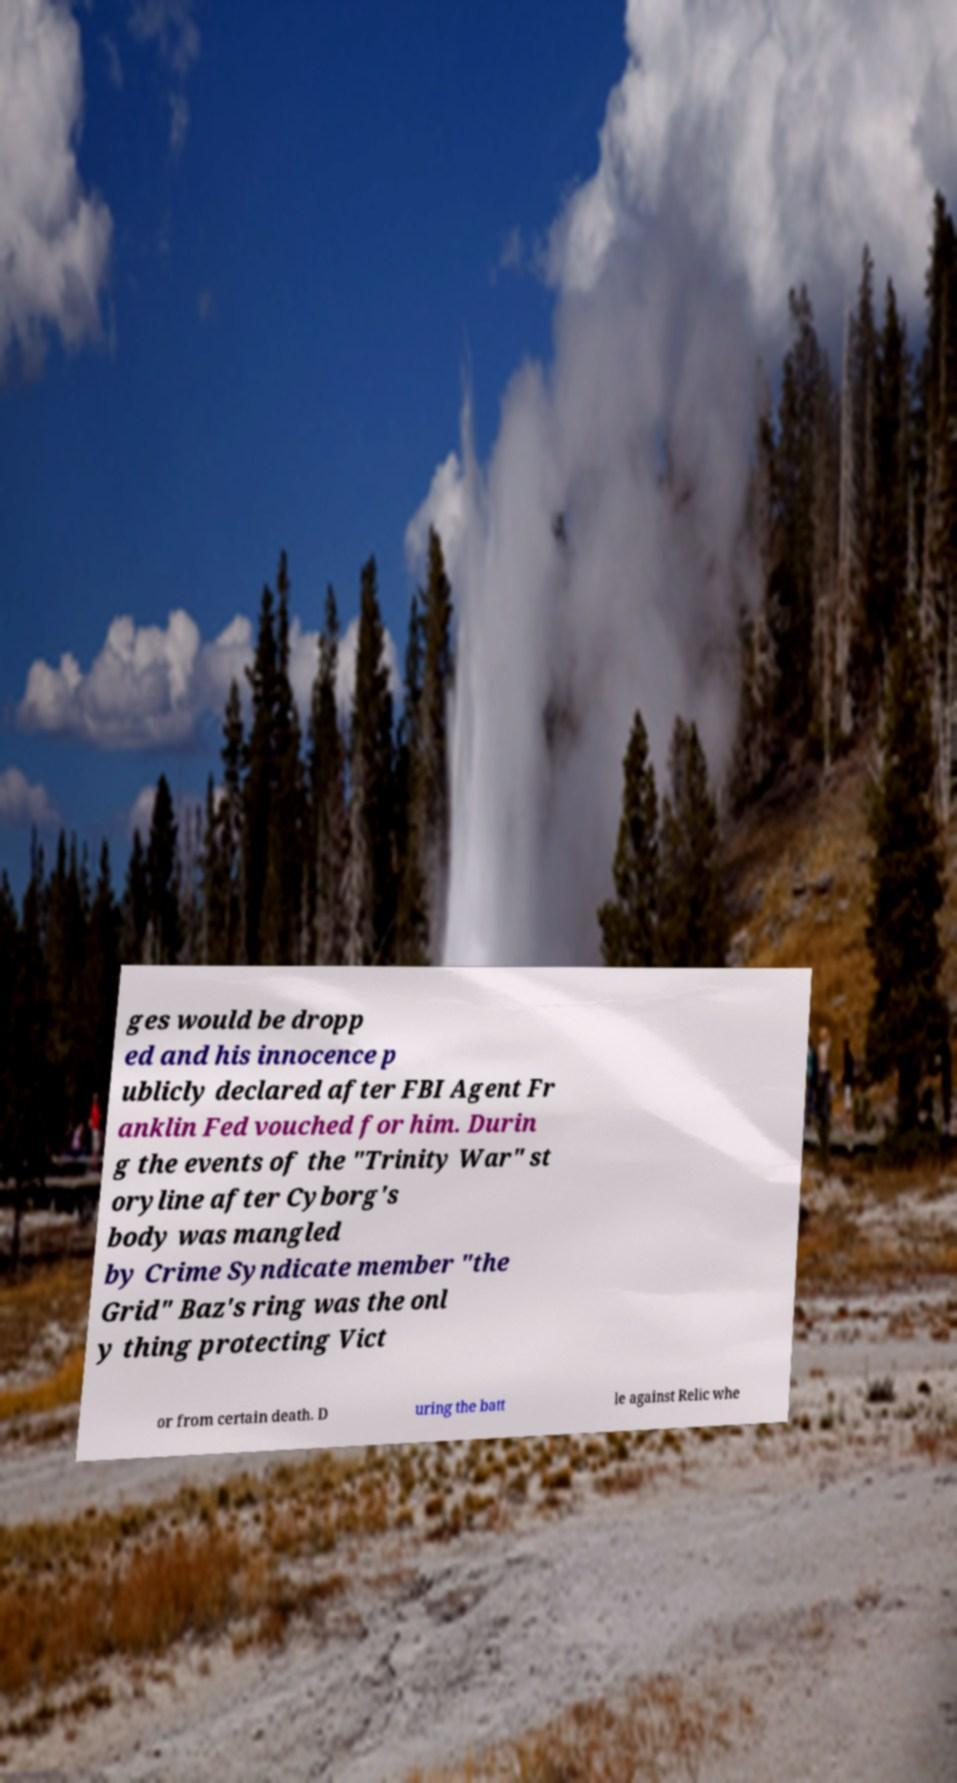What messages or text are displayed in this image? I need them in a readable, typed format. ges would be dropp ed and his innocence p ublicly declared after FBI Agent Fr anklin Fed vouched for him. Durin g the events of the "Trinity War" st oryline after Cyborg's body was mangled by Crime Syndicate member "the Grid" Baz's ring was the onl y thing protecting Vict or from certain death. D uring the batt le against Relic whe 